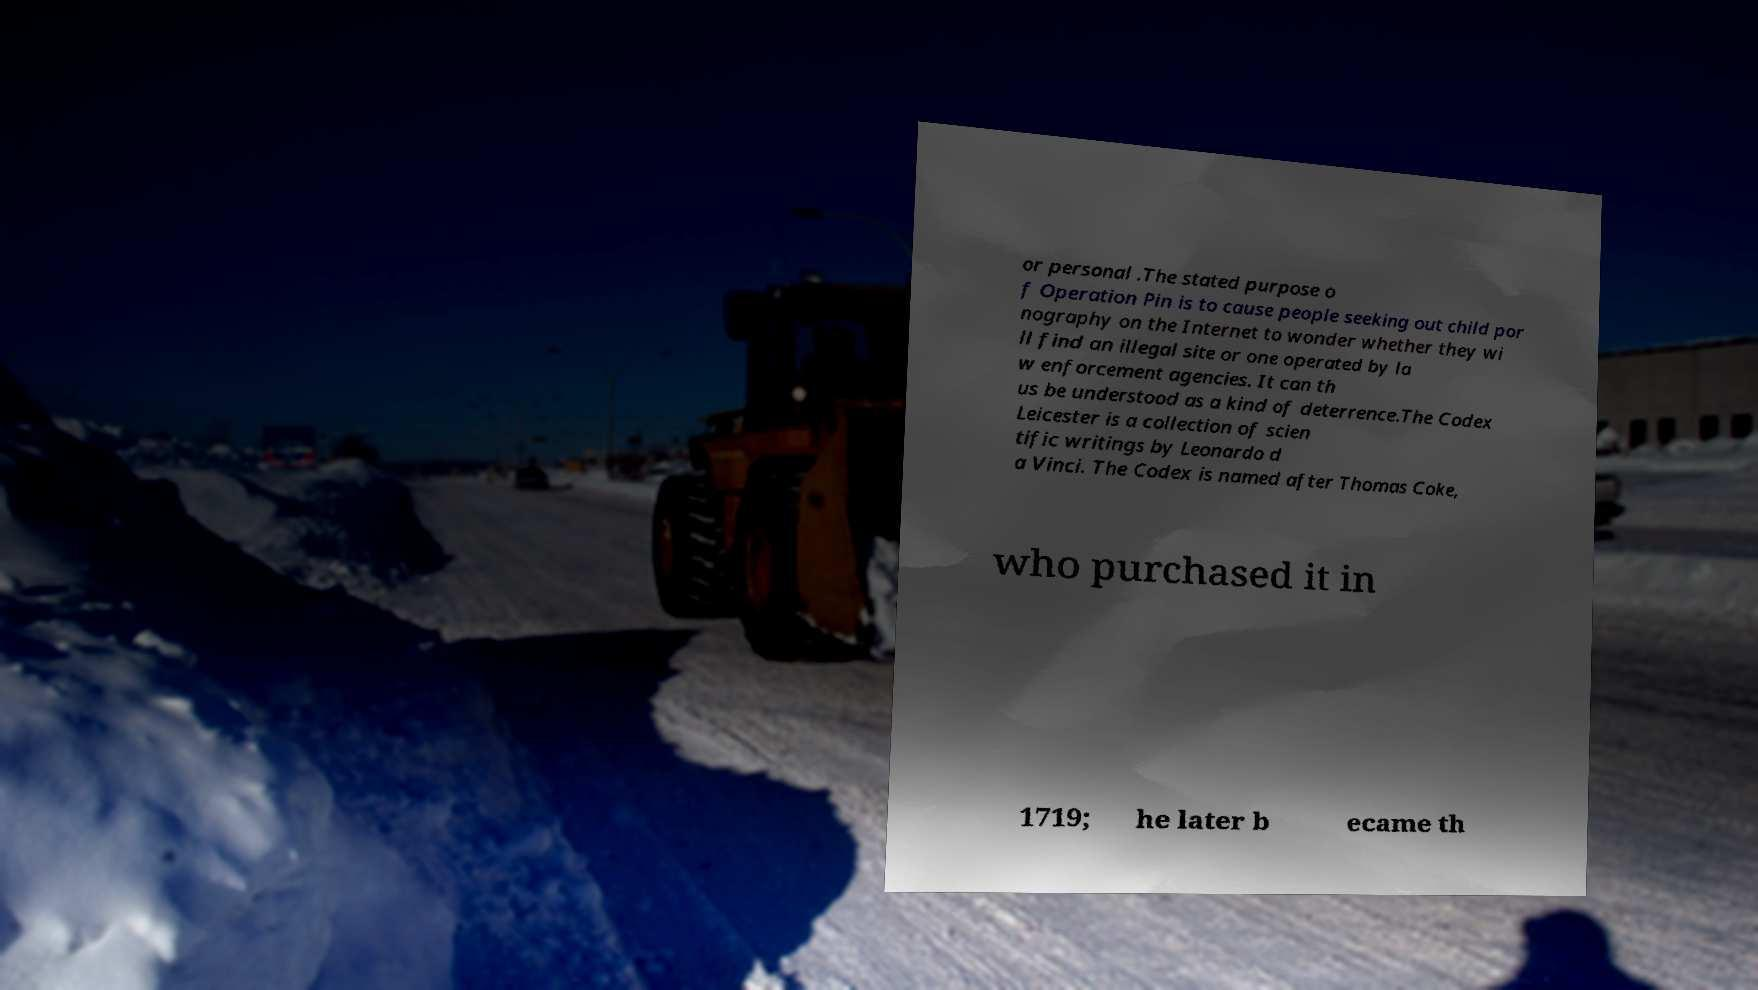Please read and relay the text visible in this image. What does it say? or personal .The stated purpose o f Operation Pin is to cause people seeking out child por nography on the Internet to wonder whether they wi ll find an illegal site or one operated by la w enforcement agencies. It can th us be understood as a kind of deterrence.The Codex Leicester is a collection of scien tific writings by Leonardo d a Vinci. The Codex is named after Thomas Coke, who purchased it in 1719; he later b ecame th 